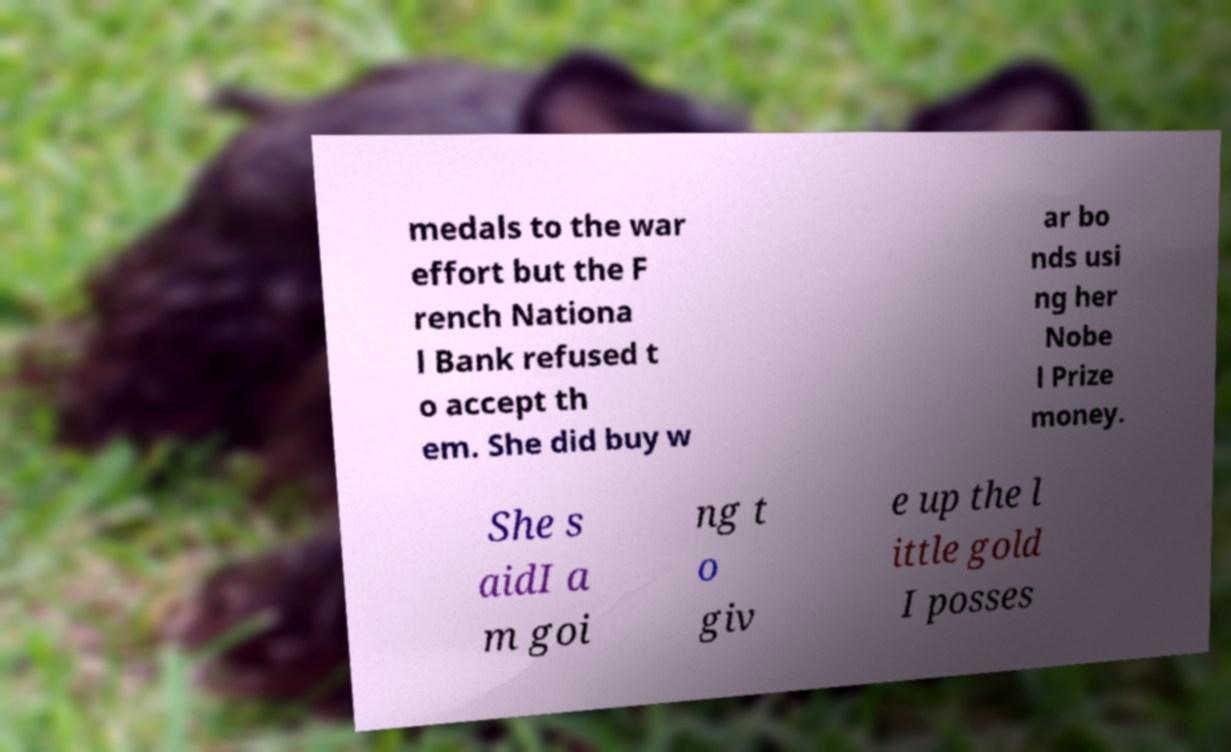Could you extract and type out the text from this image? medals to the war effort but the F rench Nationa l Bank refused t o accept th em. She did buy w ar bo nds usi ng her Nobe l Prize money. She s aidI a m goi ng t o giv e up the l ittle gold I posses 